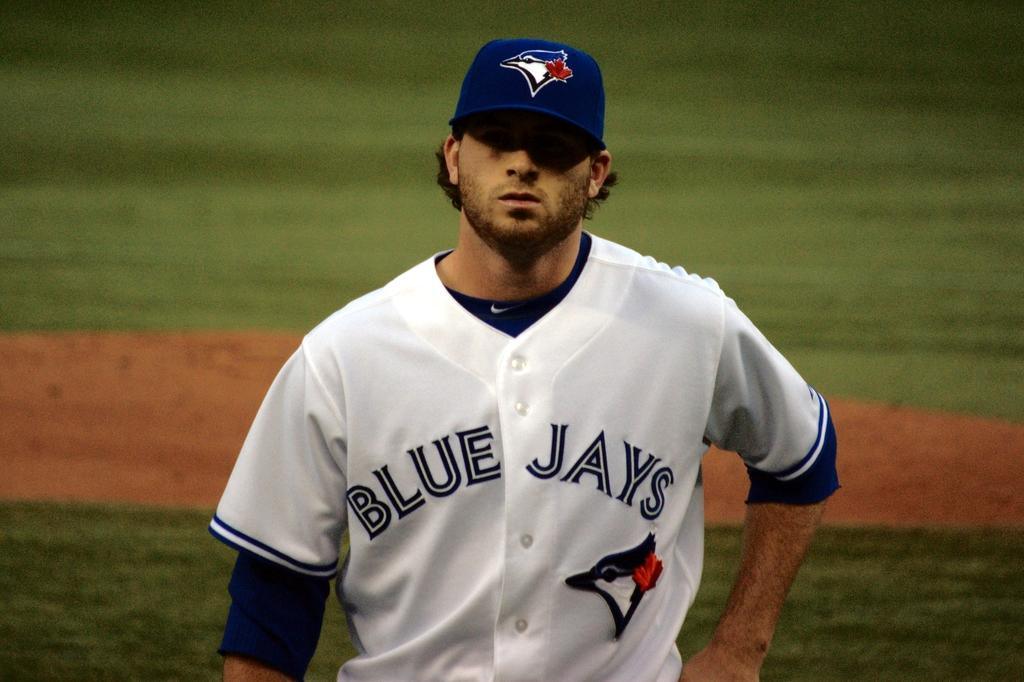Provide a one-sentence caption for the provided image. Toronto Blue Jays pitcher is looking into home plate. 